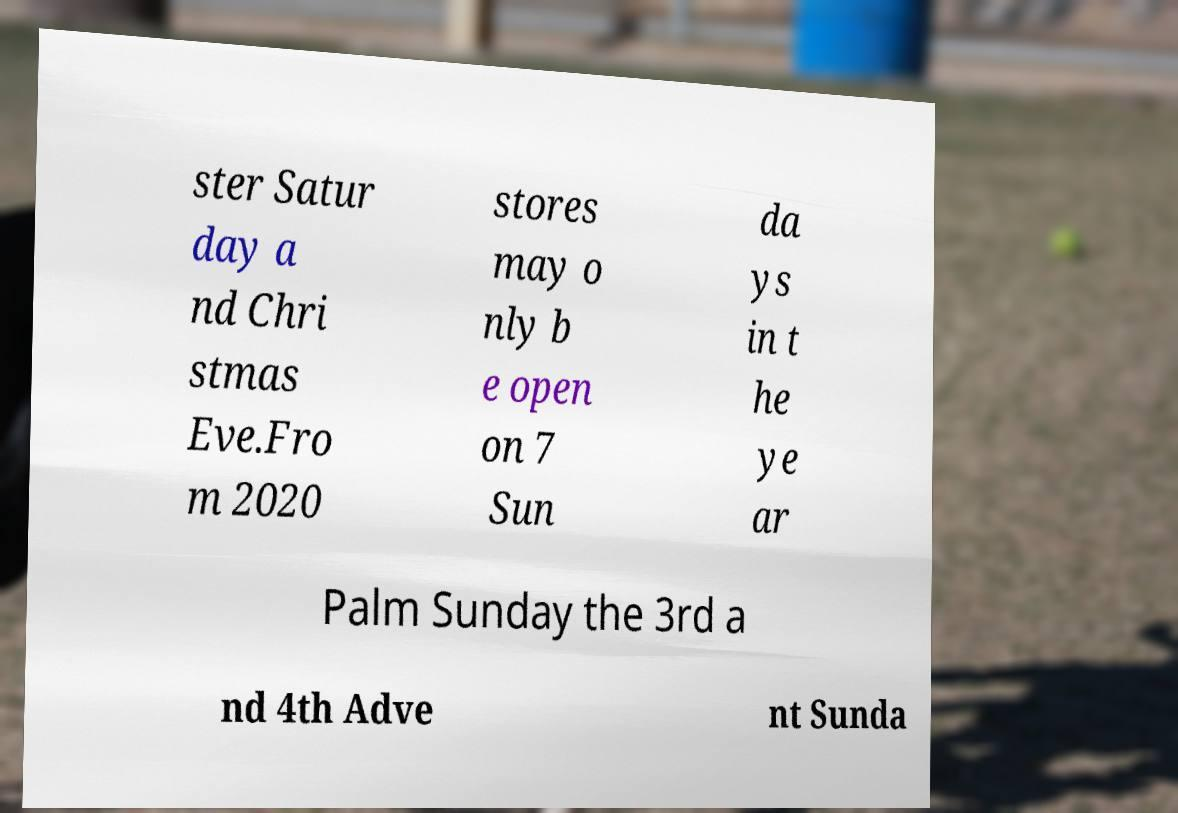Can you accurately transcribe the text from the provided image for me? ster Satur day a nd Chri stmas Eve.Fro m 2020 stores may o nly b e open on 7 Sun da ys in t he ye ar Palm Sunday the 3rd a nd 4th Adve nt Sunda 